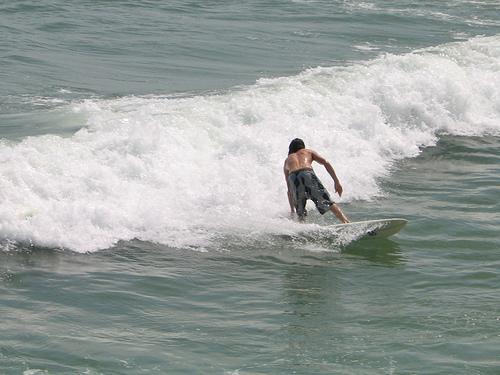What is he wearing?
Give a very brief answer. Shorts. What emotion is the surfer feeling?
Write a very short answer. Excitement. Is the surfer wearing a wetsuit?
Keep it brief. No. Is this wave challenging for an experienced surfer?
Short answer required. No. What is the man riding on the wave?
Quick response, please. Surfboard. 